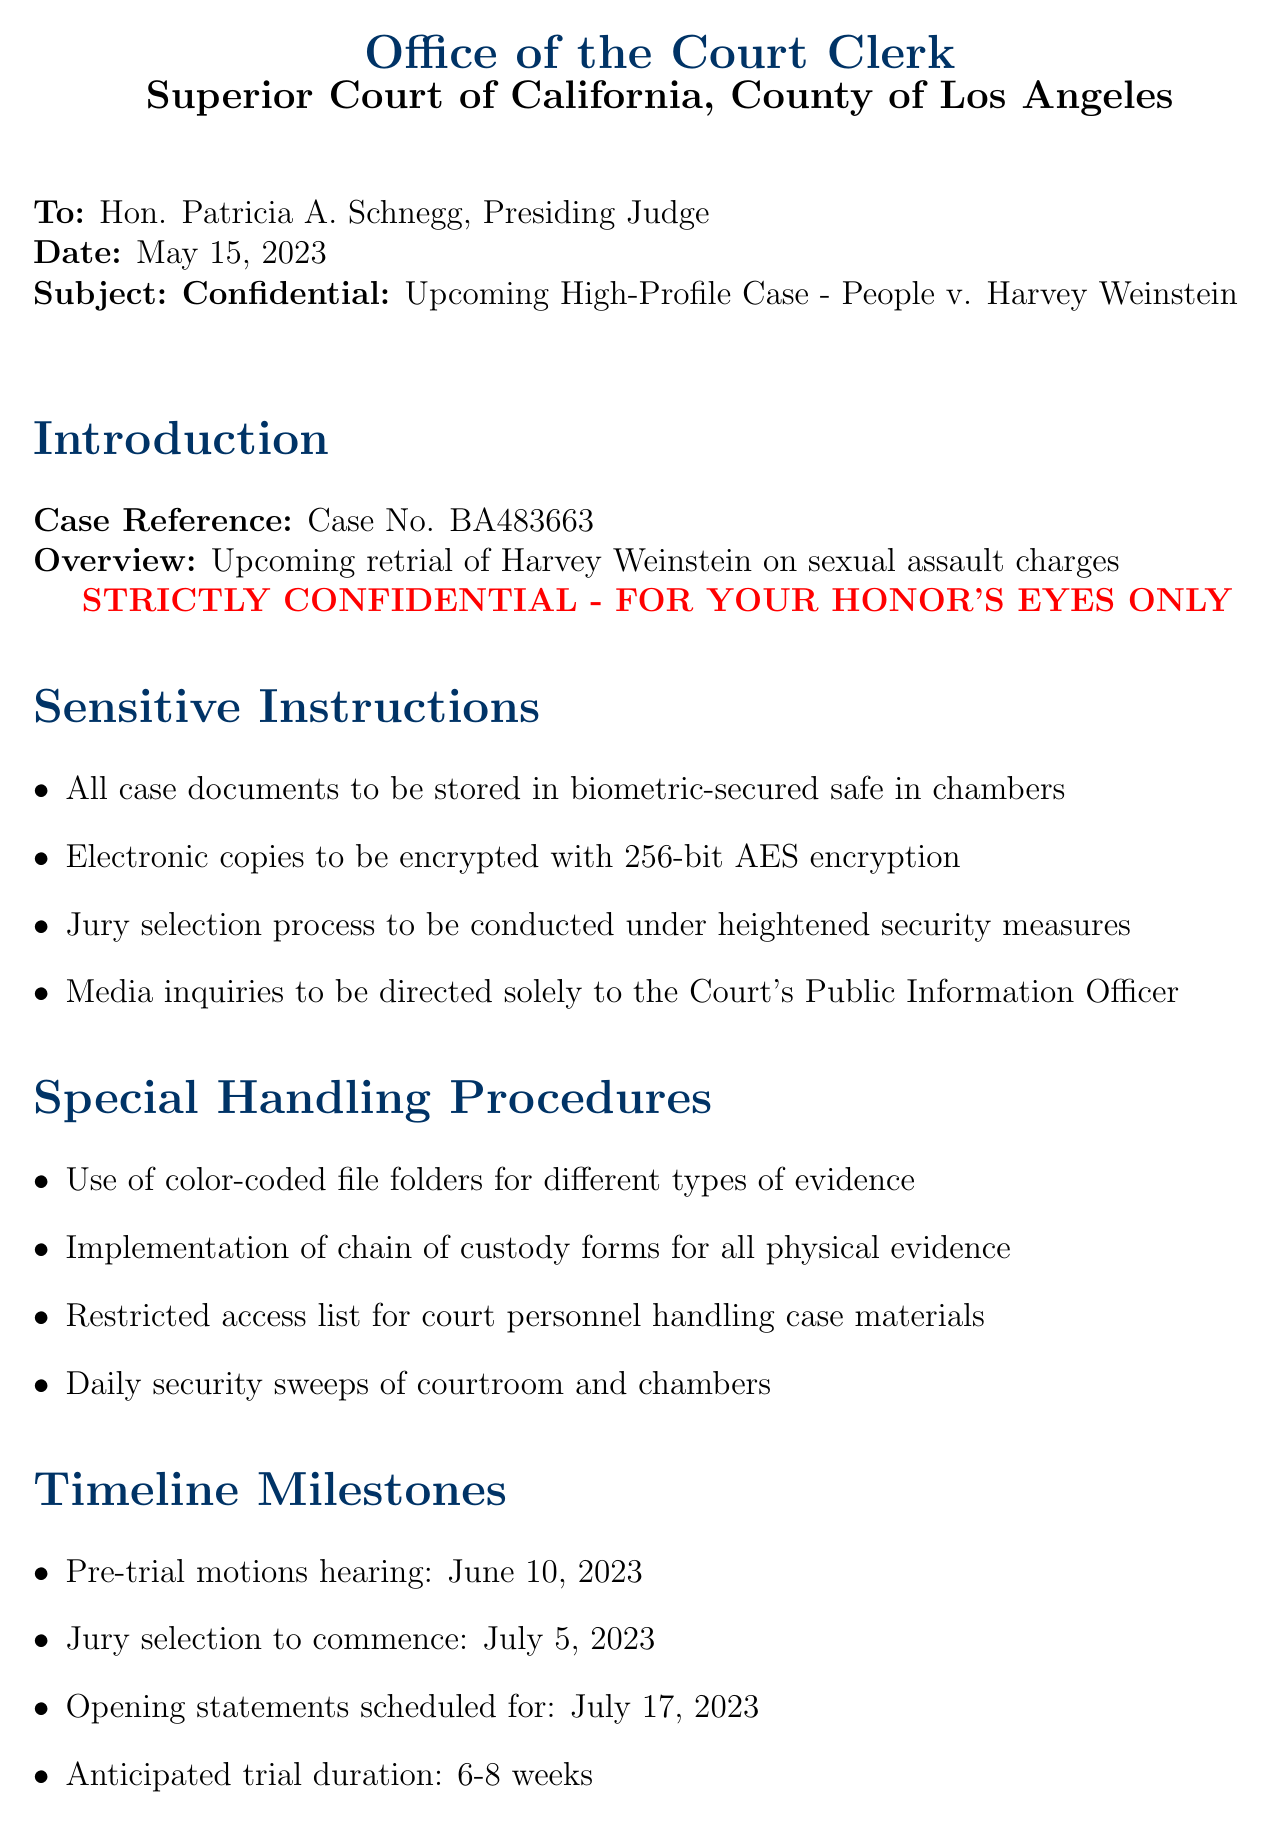What is the case reference number? The case reference number is mentioned in the introduction section of the letter.
Answer: Case No. BA483663 Who is the sender of the letter? The sender of the letter is listed at the top of the document.
Answer: Office of the Court Clerk, Superior Court of California, County of Los Angeles What is the subject of the letter? The subject is clearly stated in the subject line of the document.
Answer: Confidential: Upcoming High-Profile Case - People v. Harvey Weinstein When is the jury selection scheduled to commence? The document specifies the date for jury selection within the timeline milestones section.
Answer: July 5, 2023 What encryption standard is recommended for electronic copies? The specific encryption standard is outlined in the sensitive instructions section.
Answer: 256-bit AES encryption How many weeks is the anticipated trial duration? This is mentioned in the timeline milestones section of the letter.
Answer: 6-8 weeks Who is designated as the spokesperson for media inquiries? The designated spokesperson for media management is clearly stated in the media management section.
Answer: Ms. Ann Donlan, Court Communications Director What type of file folders should be used for evidence? The type of file folders is specified in the special handling procedures.
Answer: Color-coded file folders What security measure involves jury anonymity? The specific measure regarding juror anonymity is stated in the security measures section.
Answer: Anonymous juror system 